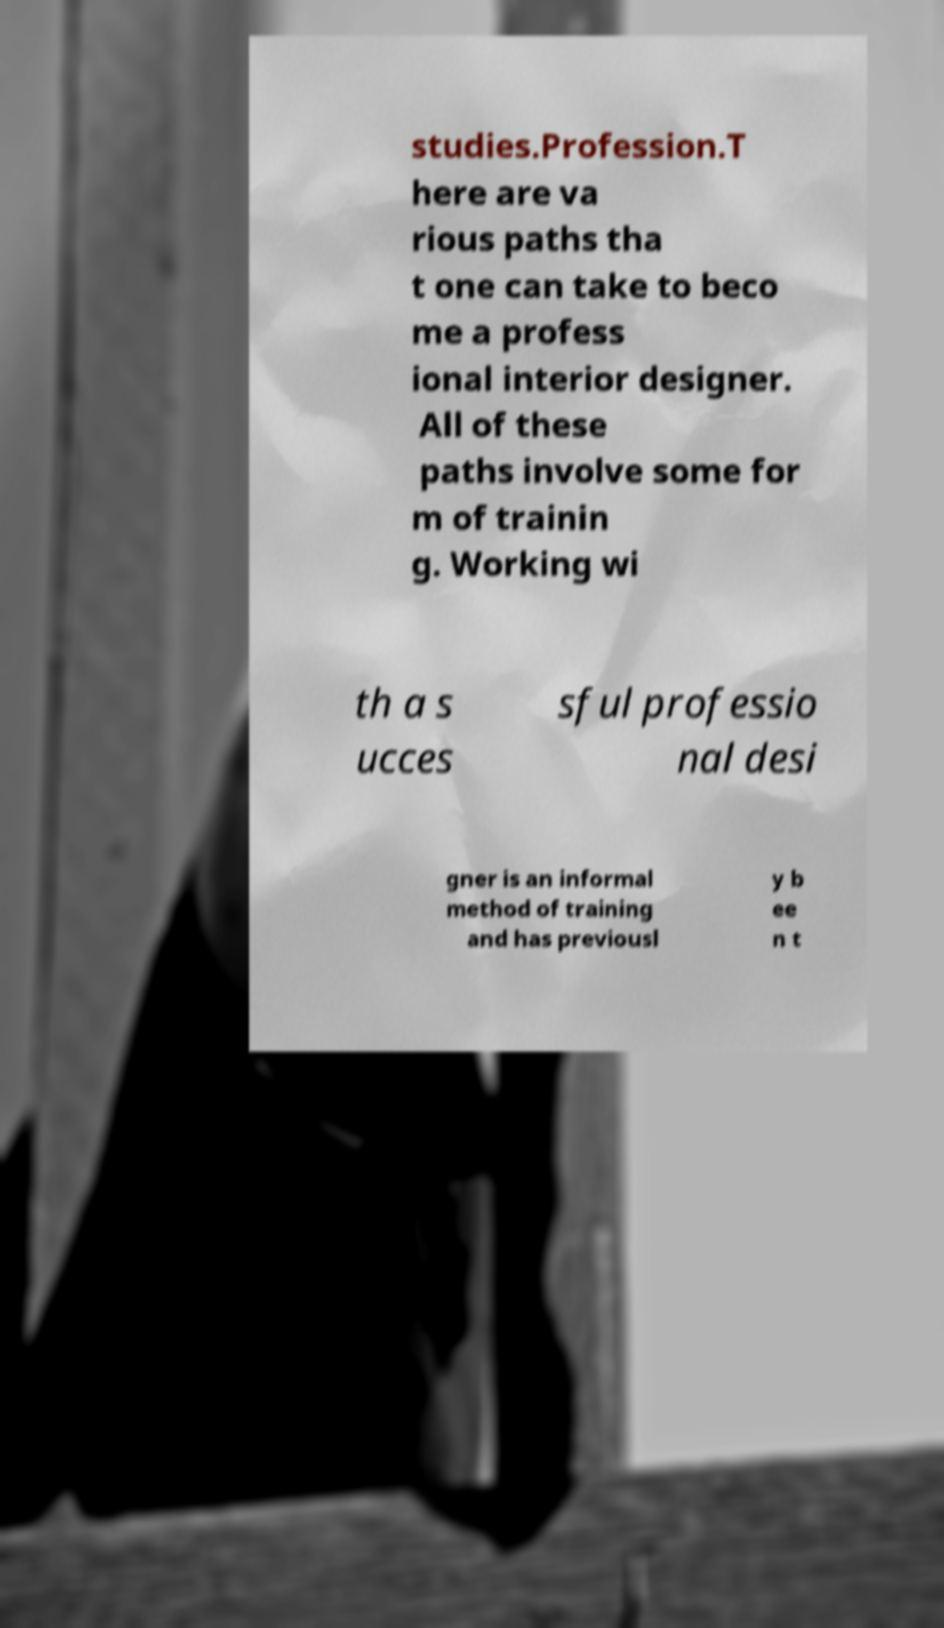Can you read and provide the text displayed in the image?This photo seems to have some interesting text. Can you extract and type it out for me? studies.Profession.T here are va rious paths tha t one can take to beco me a profess ional interior designer. All of these paths involve some for m of trainin g. Working wi th a s ucces sful professio nal desi gner is an informal method of training and has previousl y b ee n t 